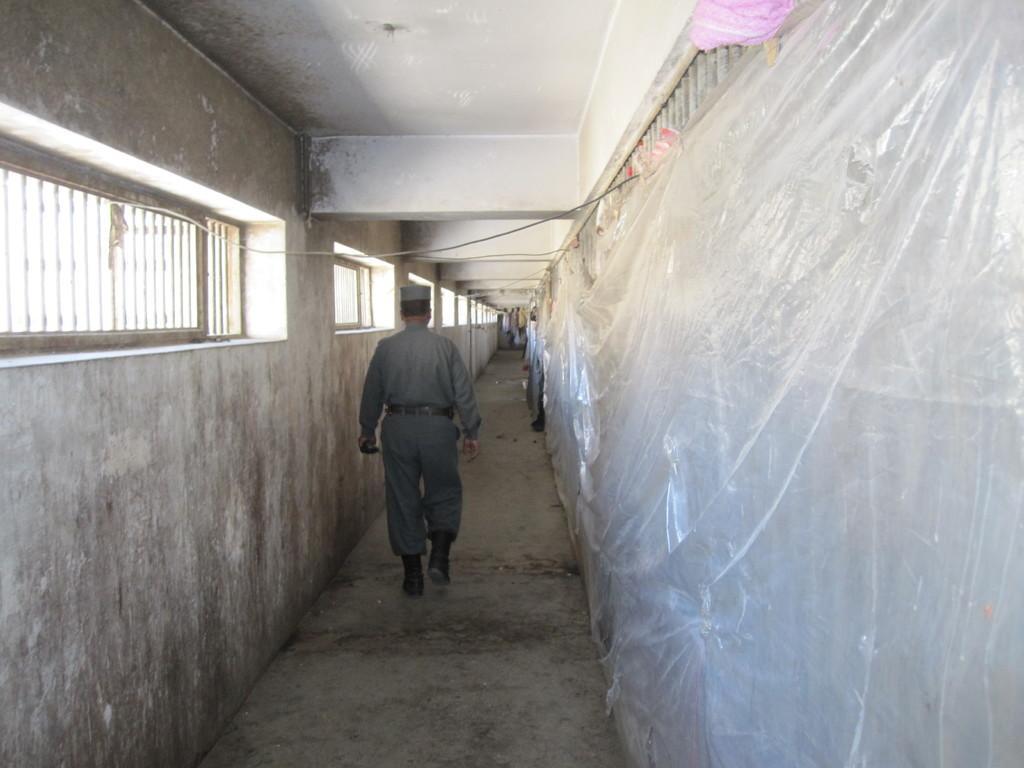Could you give a brief overview of what you see in this image? In the middle of the picture, we see the man in the uniform is walking. On the left side, we see a wall in white color. We even see the windows. On the right side, we see a sheet or cover. At the top, we see the roof of the building. 